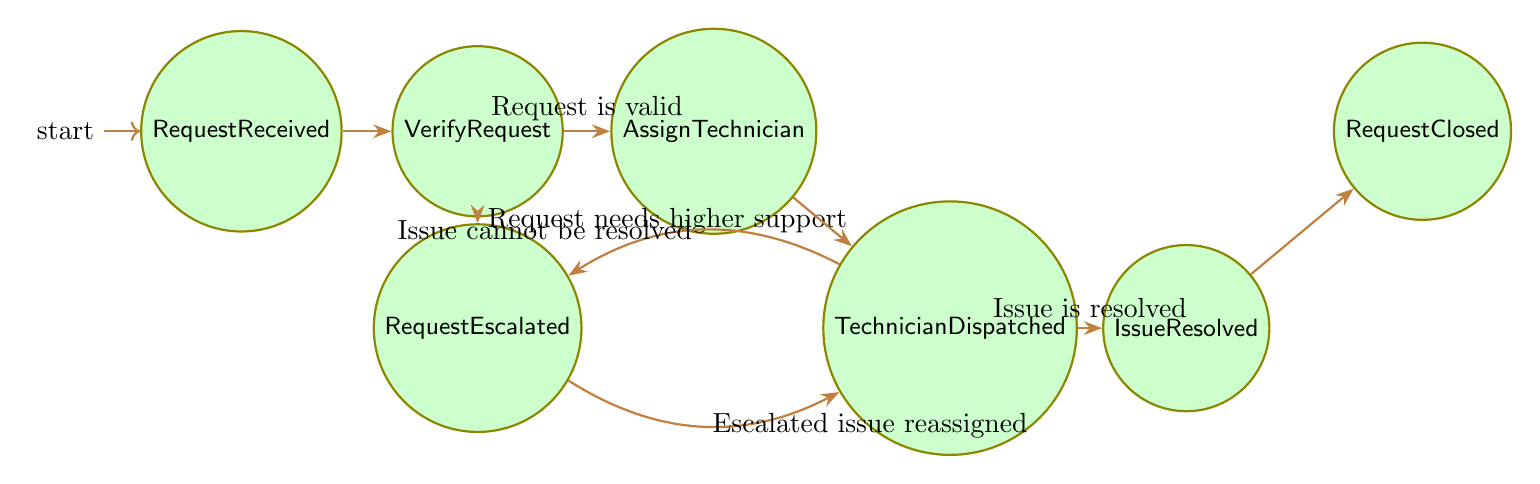What is the initial state of the process? The diagram starts with 'RequestReceived', indicating the first state in the customer service request process.
Answer: RequestReceived How many states are present in the diagram? By counting each unique state in the diagram—RequestReceived, VerifyRequest, AssignTechnician, TechnicianDispatched, IssueResolved, RequestClosed, and RequestEscalated—I find there are seven states.
Answer: 7 What transition occurs after verifying the request if it is valid? If the request is verified and found valid, the transition leads to 'AssignTechnician', which is the next state in the sequence.
Answer: AssignTechnician What does the request escalate to? The diagram shows that if a request needs higher support, the transition will lead to 'RequestEscalated'.
Answer: RequestEscalated What state precedes the 'RequestClosed' state? The state leading into 'RequestClosed' is 'IssueResolved', as it is the last action before closing the request.
Answer: IssueResolved What is the relationship between 'TechnicianDispatched' and 'RequestEscalated'? From 'TechnicianDispatched', a transition can occur to 'RequestEscalated' if the issue cannot be resolved at the current level, indicating a flow of complexity in service handling.
Answer: RequestEscalated If a request is escalated, where does it go next? Once in 'RequestEscalated', the next action can lead back to 'TechnicianDispatched' if the escalated issue is reassigned to a technician.
Answer: TechnicianDispatched How many transitions lead out of 'VerifyRequest'? There are two transitions from 'VerifyRequest': one goes to 'AssignTechnician' if the request is valid, and another to 'RequestEscalated' if it needs higher support, making a total of two.
Answer: 2 